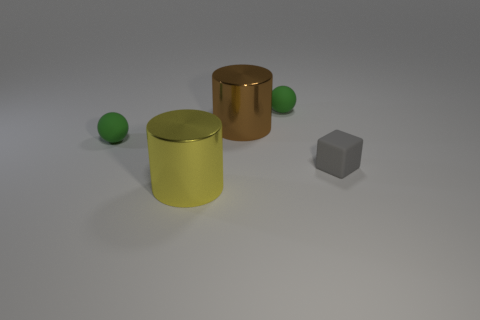Add 4 large brown spheres. How many objects exist? 9 Subtract all cylinders. How many objects are left? 3 Subtract all tiny green matte objects. Subtract all blocks. How many objects are left? 2 Add 2 rubber cubes. How many rubber cubes are left? 3 Add 4 blue metal cylinders. How many blue metal cylinders exist? 4 Subtract 0 purple balls. How many objects are left? 5 Subtract all purple cylinders. Subtract all brown blocks. How many cylinders are left? 2 